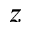Convert formula to latex. <formula><loc_0><loc_0><loc_500><loc_500>z</formula> 